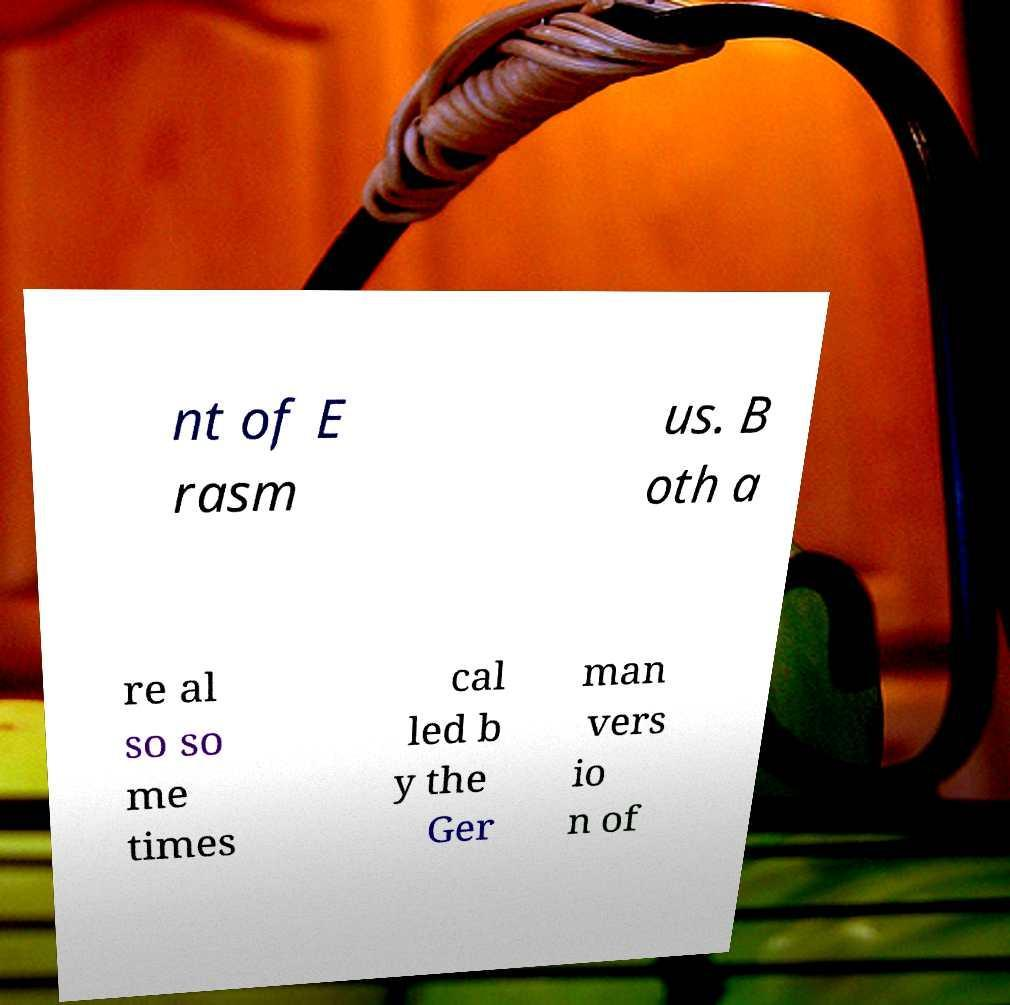Can you accurately transcribe the text from the provided image for me? nt of E rasm us. B oth a re al so so me times cal led b y the Ger man vers io n of 